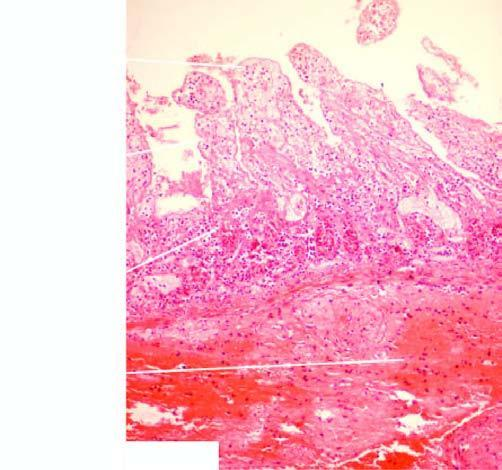what is also partly affected?
Answer the question using a single word or phrase. Muscularis 